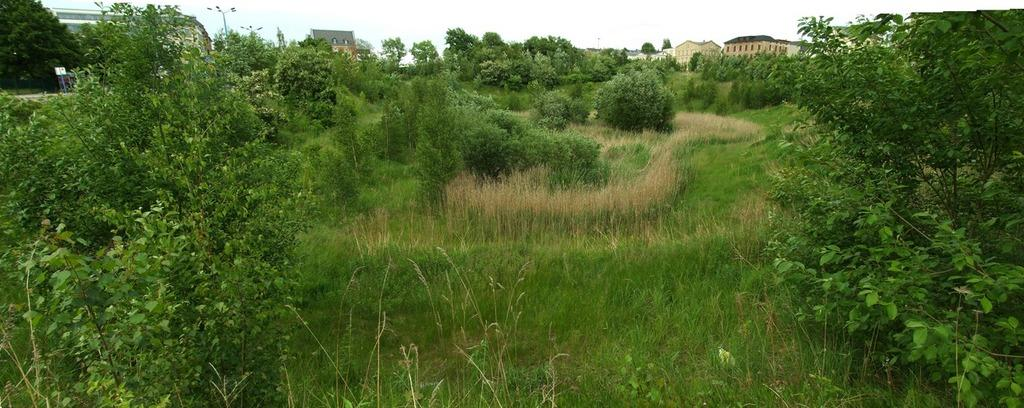What type of vegetation is present in the front of the image? There is grass and plants in the front of the image. What can be seen in the background of the image? There are trees, buildings, poles, and the sky visible in the background of the image. Can you see a coach driving through the lake in the image? There is no coach or lake present in the image. What is the thumb doing in the image? There is no thumb visible in the image. 